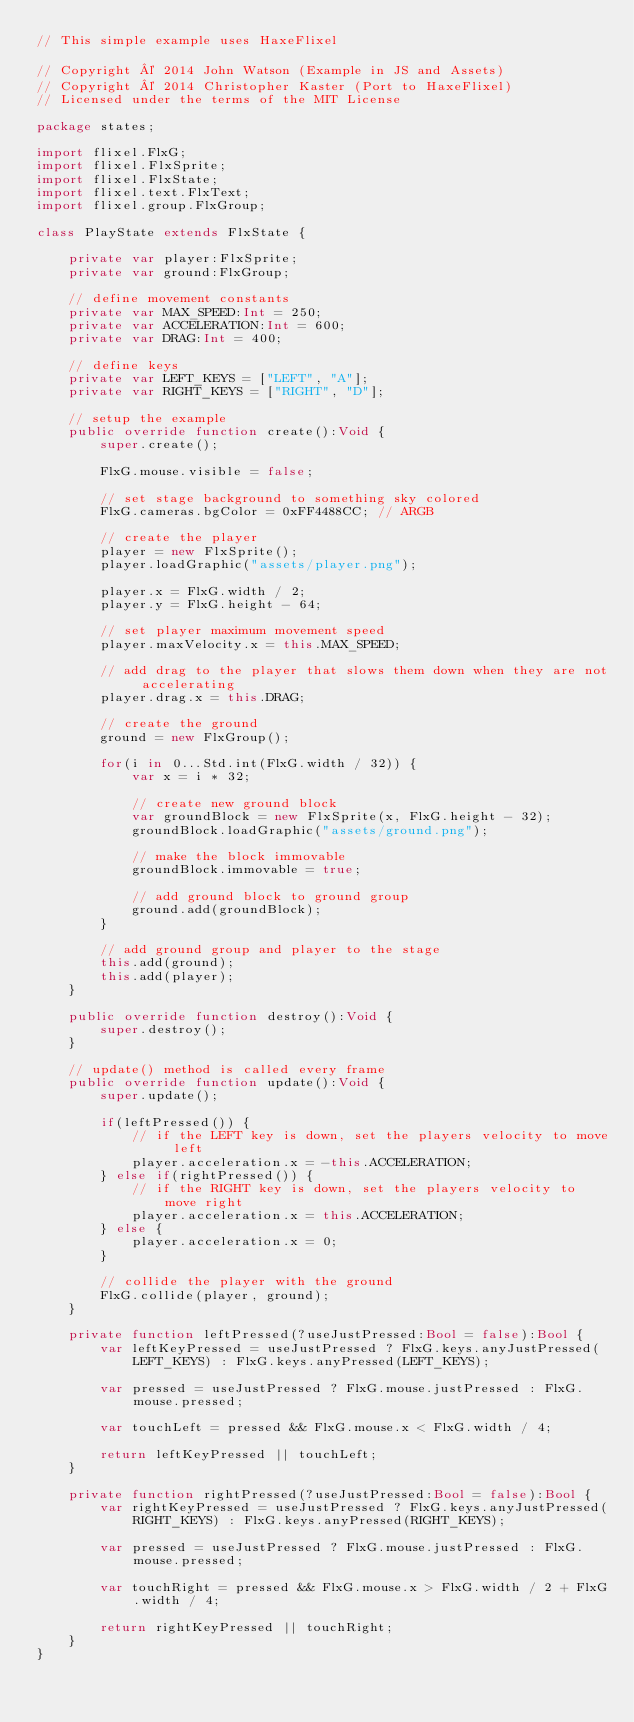Convert code to text. <code><loc_0><loc_0><loc_500><loc_500><_Haxe_>// This simple example uses HaxeFlixel

// Copyright © 2014 John Watson (Example in JS and Assets)
// Copyright © 2014 Christopher Kaster (Port to HaxeFlixel)
// Licensed under the terms of the MIT License

package states;

import flixel.FlxG;
import flixel.FlxSprite;
import flixel.FlxState;
import flixel.text.FlxText;
import flixel.group.FlxGroup;

class PlayState extends FlxState {

	private var player:FlxSprite;
	private var ground:FlxGroup;

	// define movement constants
	private var MAX_SPEED:Int = 250;
	private var ACCELERATION:Int = 600;
	private var DRAG:Int = 400;

	// define keys
	private var LEFT_KEYS = ["LEFT", "A"];
	private var RIGHT_KEYS = ["RIGHT", "D"];

	// setup the example
	public override function create():Void {
		super.create();

		FlxG.mouse.visible = false;

		// set stage background to something sky colored
		FlxG.cameras.bgColor = 0xFF4488CC; // ARGB

		// create the player
		player = new FlxSprite();
		player.loadGraphic("assets/player.png");

		player.x = FlxG.width / 2;
		player.y = FlxG.height - 64;

		// set player maximum movement speed
		player.maxVelocity.x = this.MAX_SPEED;

		// add drag to the player that slows them down when they are not accelerating
		player.drag.x = this.DRAG;

		// create the ground
		ground = new FlxGroup();

		for(i in 0...Std.int(FlxG.width / 32)) {
			var x = i * 32;

			// create new ground block
			var groundBlock = new FlxSprite(x, FlxG.height - 32);
			groundBlock.loadGraphic("assets/ground.png");

			// make the block immovable
			groundBlock.immovable = true;

			// add ground block to ground group
			ground.add(groundBlock);
		}

		// add ground group and player to the stage
		this.add(ground);
		this.add(player);
	}

	public override function destroy():Void {
		super.destroy();
	}

	// update() method is called every frame
	public override function update():Void {
		super.update();

		if(leftPressed()) {
			// if the LEFT key is down, set the players velocity to move left
			player.acceleration.x = -this.ACCELERATION;
		} else if(rightPressed()) {
			// if the RIGHT key is down, set the players velocity to move right
			player.acceleration.x = this.ACCELERATION;
		} else {
			player.acceleration.x = 0;
		}

		// collide the player with the ground
		FlxG.collide(player, ground);
	}

	private function leftPressed(?useJustPressed:Bool = false):Bool {
		var leftKeyPressed = useJustPressed ? FlxG.keys.anyJustPressed(LEFT_KEYS) : FlxG.keys.anyPressed(LEFT_KEYS);

		var pressed = useJustPressed ? FlxG.mouse.justPressed : FlxG.mouse.pressed;

		var touchLeft = pressed && FlxG.mouse.x < FlxG.width / 4;

		return leftKeyPressed || touchLeft;
	}

	private function rightPressed(?useJustPressed:Bool = false):Bool {
		var rightKeyPressed = useJustPressed ? FlxG.keys.anyJustPressed(RIGHT_KEYS) : FlxG.keys.anyPressed(RIGHT_KEYS);

		var pressed = useJustPressed ? FlxG.mouse.justPressed : FlxG.mouse.pressed;

		var touchRight = pressed && FlxG.mouse.x > FlxG.width / 2 + FlxG.width / 4;

		return rightKeyPressed || touchRight;
	}
}</code> 